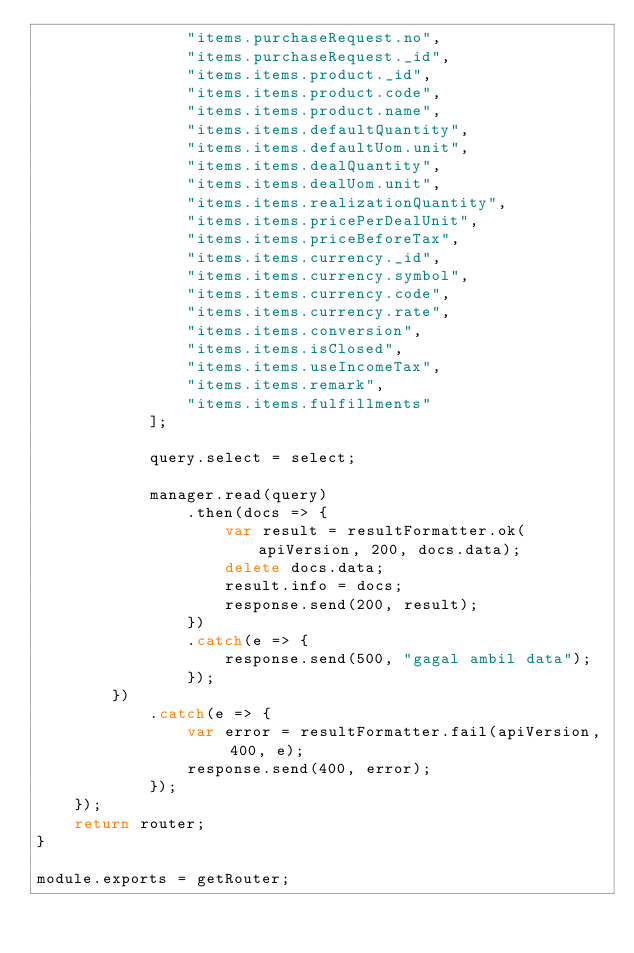<code> <loc_0><loc_0><loc_500><loc_500><_JavaScript_>                "items.purchaseRequest.no",
                "items.purchaseRequest._id",
                "items.items.product._id",
                "items.items.product.code",
                "items.items.product.name",
                "items.items.defaultQuantity",
                "items.items.defaultUom.unit",
                "items.items.dealQuantity",
                "items.items.dealUom.unit",
                "items.items.realizationQuantity",
                "items.items.pricePerDealUnit",
                "items.items.priceBeforeTax",
                "items.items.currency._id",
                "items.items.currency.symbol",
                "items.items.currency.code",
                "items.items.currency.rate",
                "items.items.conversion",
                "items.items.isClosed",
                "items.items.useIncomeTax",
                "items.items.remark",
                "items.items.fulfillments"
            ];

            query.select = select;

            manager.read(query)
                .then(docs => {
                    var result = resultFormatter.ok(apiVersion, 200, docs.data);
                    delete docs.data;
                    result.info = docs;
                    response.send(200, result);
                })
                .catch(e => {
                    response.send(500, "gagal ambil data");
                });
        })
            .catch(e => {
                var error = resultFormatter.fail(apiVersion, 400, e);
                response.send(400, error);
            });
    });
    return router;
}

module.exports = getRouter;</code> 